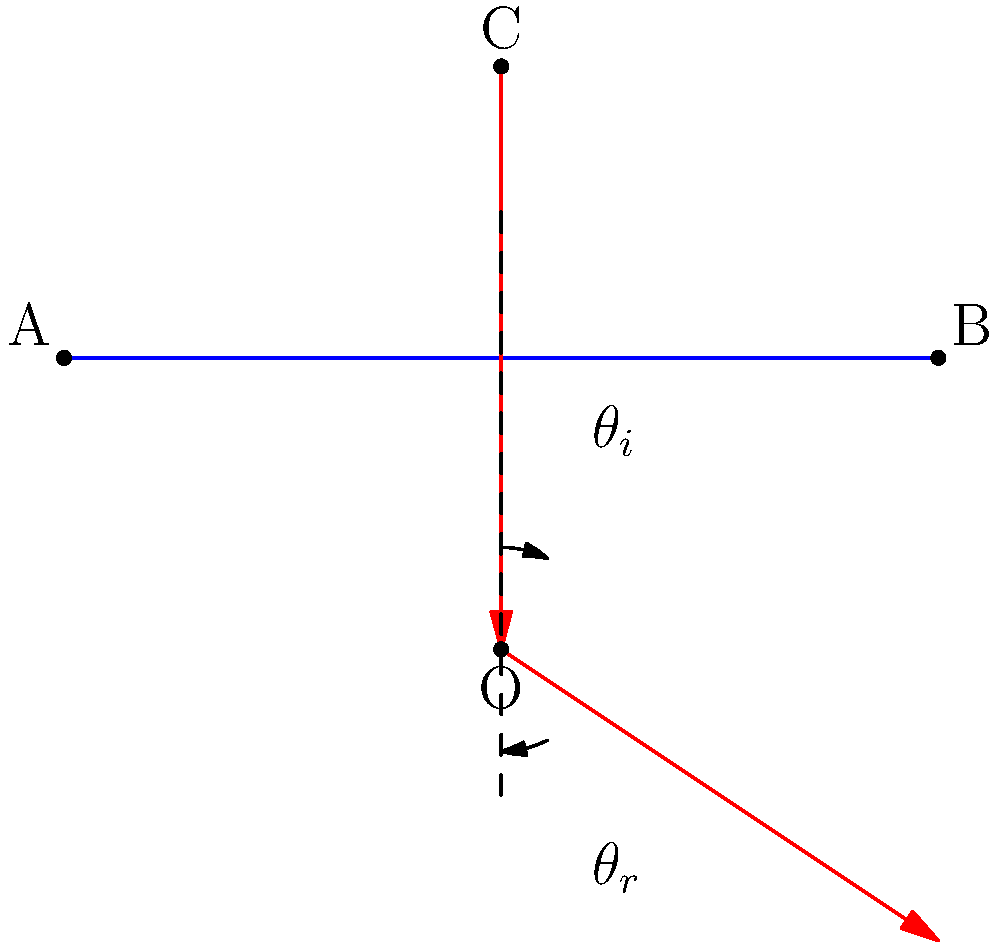In a pivotal scene of a noir film, a character observes a reflection in a mirror. The cinematographer wants to emphasize this moment by precisely controlling the light. Using the ray diagram provided, which illustrates the law of reflection, explain how this principle is applied in cinematography. How does this visual technique relate to Fredric Jameson's concept of "cognitive mapping" in postmodern cinema? 1. The law of reflection states that the angle of incidence ($\theta_i$) equals the angle of reflection ($\theta_r$). This is clearly illustrated in the diagram.

2. In cinematography, this principle is crucial for controlling lighting and creating specific visual effects:
   a) Bounce lighting: Cinematographers use reflective surfaces to indirect light onto subjects, creating softer illumination.
   b) Practical mirror shots: When filming scenes with mirrors, understanding reflection angles helps in positioning cameras to avoid unwanted reflections.

3. The precision of light control in this scene connects to Jameson's "cognitive mapping" in several ways:
   a) Visual representation of complex ideas: The careful use of reflection can symbolize the character's self-reflection or fragmented identity, common themes in postmodern cinema.
   b) Spatial awareness: The mirror shot creates a sense of expanded space, challenging the viewer's perception of the film's geography - a key aspect of cognitive mapping.
   c) Layered meaning: The controlled reflection adds visual depth, potentially representing the multi-layered nature of postmodern narratives that Jameson often discusses.

4. By manipulating light using the law of reflection, the cinematographer creates a visual metaphor that aligns with Jameson's ideas about how postmodern art helps us understand our place in a complex world.

5. This technique not only serves the practical purpose of illumination but also contributes to the film's aesthetic and theoretical underpinnings, demonstrating how technical knowledge (physics of light) intersects with artistic and philosophical concepts in cinema.
Answer: The law of reflection ($\theta_i = \theta_r$) allows precise light control in cinematography, creating visual metaphors that align with Jameson's concept of cognitive mapping in postmodern cinema. 